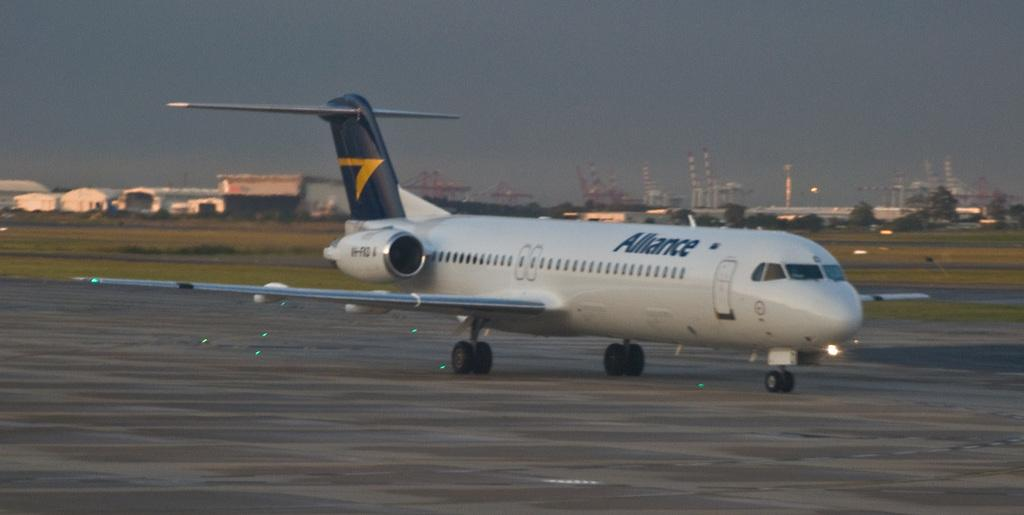Provide a one-sentence caption for the provided image. a plane with the word 'alliance' on the side of it. 